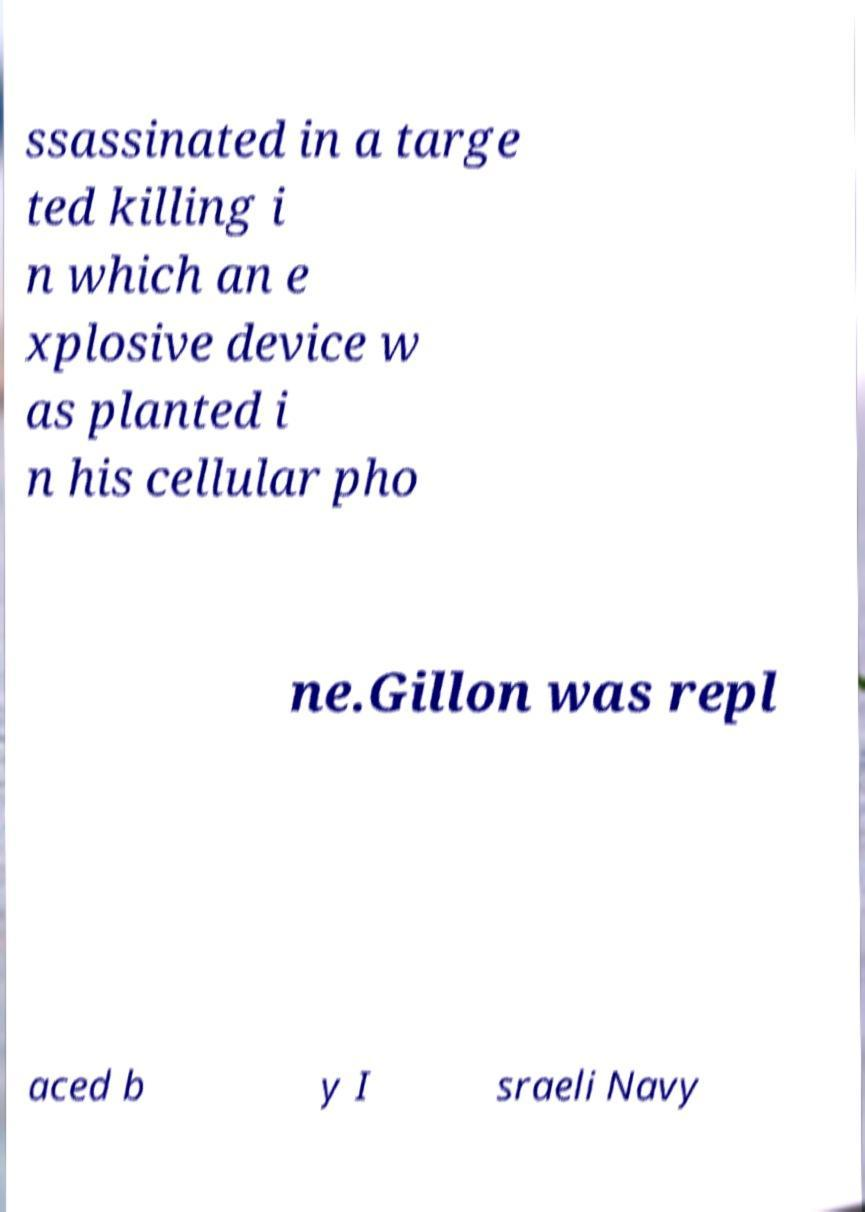Please identify and transcribe the text found in this image. ssassinated in a targe ted killing i n which an e xplosive device w as planted i n his cellular pho ne.Gillon was repl aced b y I sraeli Navy 